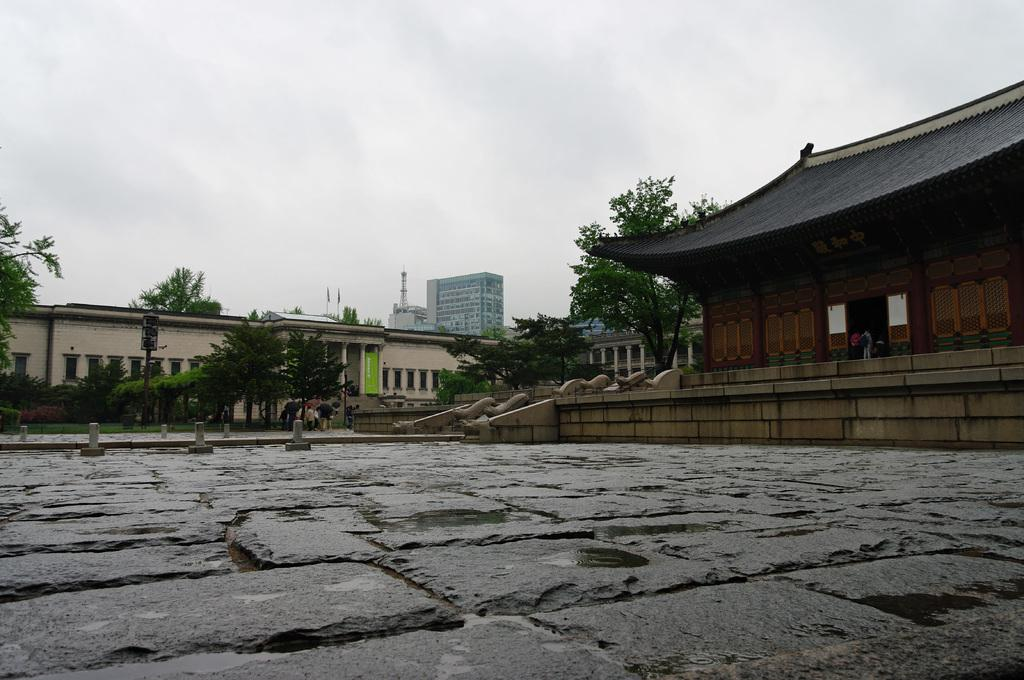What types of structures can be seen in the image? There are houses, buildings, and towers in the image. What is the purpose of the fence in the image? The purpose of the fence is to separate or enclose areas in the image. What type of vegetation is present in the image? There are trees in the image. What are the light poles used for in the image? The light poles are used for providing illumination in the image. What is the group of people doing in the image? The group of people is on the road in the image, but their specific activity is not clear. What is visible in the sky in the image? The sky is visible in the image, but no specific details about the sky are mentioned. What theory is being discussed by the group of people on the road in the image? There is no indication in the image that the group of people is discussing any theory. What property is being sold in the image? There is no indication in the image that any property is being sold. 